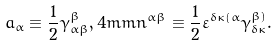<formula> <loc_0><loc_0><loc_500><loc_500>a _ { \alpha } \equiv \frac { 1 } { 2 } \gamma _ { \alpha \beta } ^ { \beta } , 4 m m n ^ { \alpha \beta } \equiv \frac { 1 } { 2 } \varepsilon ^ { \delta \kappa ( \alpha } \gamma _ { \delta \kappa } ^ { \beta ) } .</formula> 